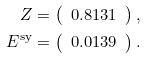Convert formula to latex. <formula><loc_0><loc_0><loc_500><loc_500>Z & = \left ( \begin{array} { c } 0 . 8 1 3 1 \end{array} \right ) , \\ E ^ { \text {sy} } & = \left ( \begin{array} { c } 0 . 0 1 3 9 \end{array} \right ) .</formula> 